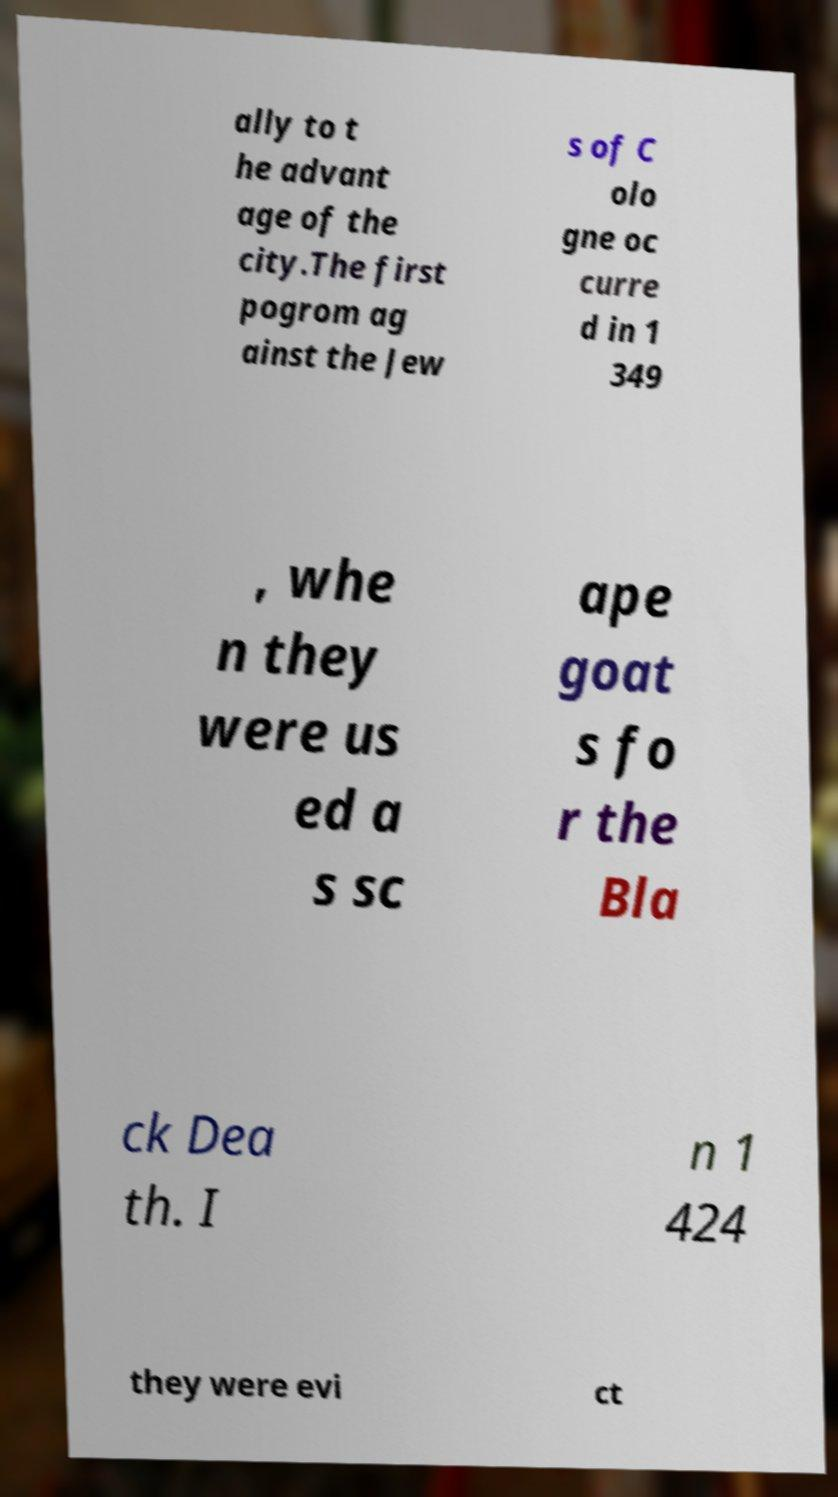For documentation purposes, I need the text within this image transcribed. Could you provide that? ally to t he advant age of the city.The first pogrom ag ainst the Jew s of C olo gne oc curre d in 1 349 , whe n they were us ed a s sc ape goat s fo r the Bla ck Dea th. I n 1 424 they were evi ct 